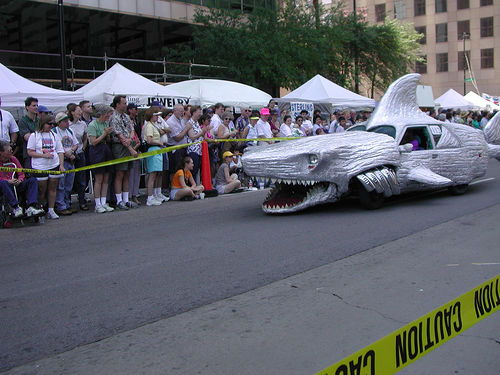<image>
Is the shark car on the road? Yes. Looking at the image, I can see the shark car is positioned on top of the road, with the road providing support. 